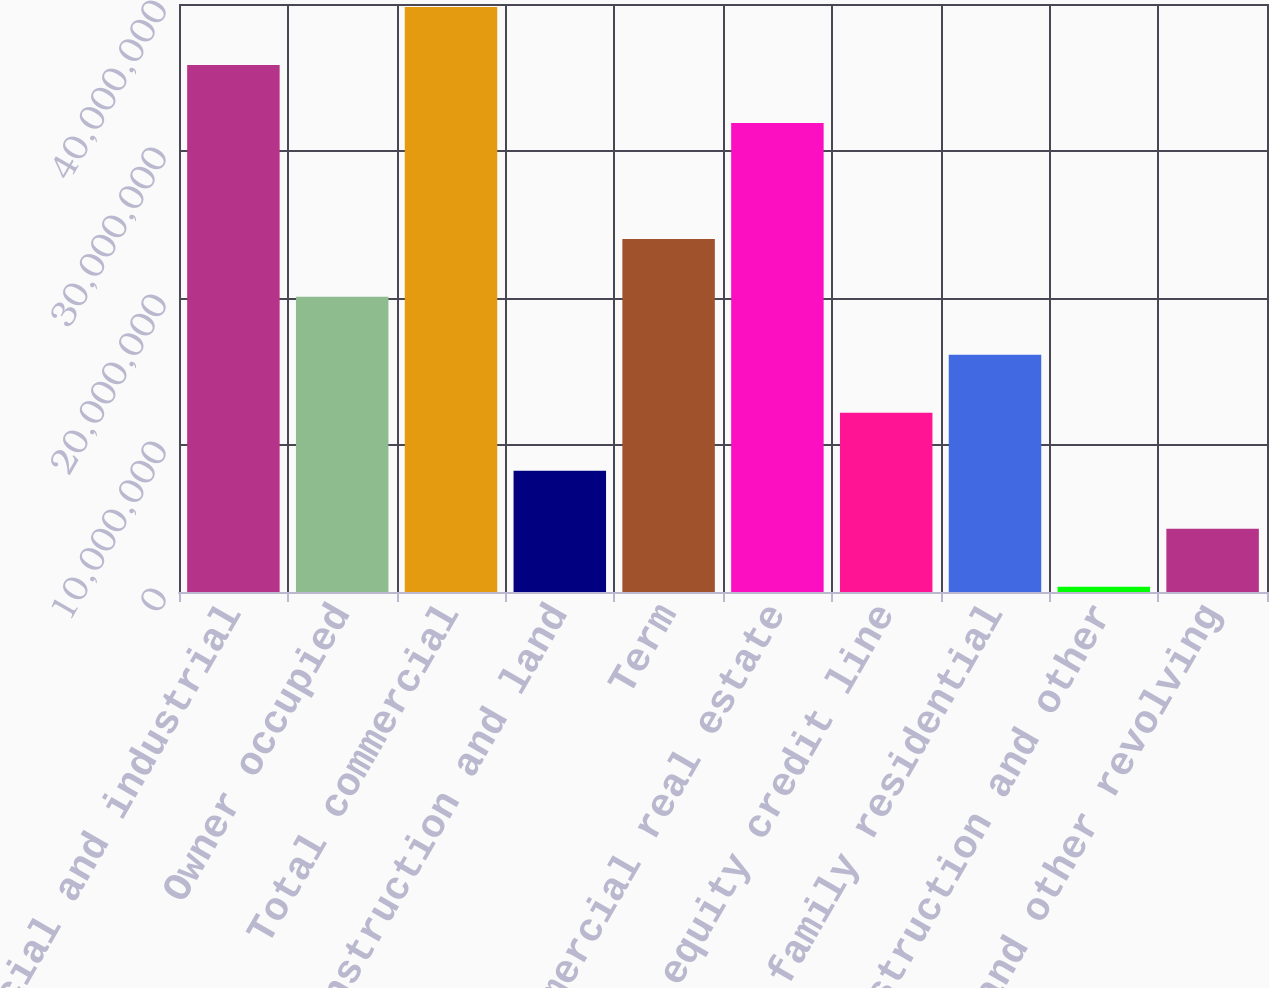Convert chart. <chart><loc_0><loc_0><loc_500><loc_500><bar_chart><fcel>Commercial and industrial<fcel>Owner occupied<fcel>Total commercial<fcel>Construction and land<fcel>Term<fcel>Total commercial real estate<fcel>Home equity credit line<fcel>1-4 family residential<fcel>Construction and other<fcel>Bankcard and other revolving<nl><fcel>3.58528e+07<fcel>2.00781e+07<fcel>3.97964e+07<fcel>8.24706e+06<fcel>2.40217e+07<fcel>3.19091e+07<fcel>1.21907e+07<fcel>1.61344e+07<fcel>359723<fcel>4.30339e+06<nl></chart> 